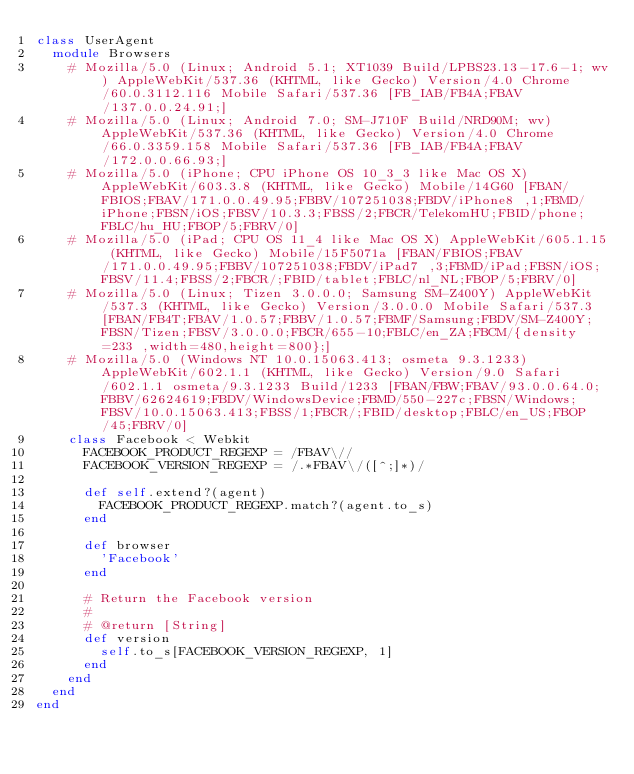Convert code to text. <code><loc_0><loc_0><loc_500><loc_500><_Ruby_>class UserAgent
  module Browsers
    # Mozilla/5.0 (Linux; Android 5.1; XT1039 Build/LPBS23.13-17.6-1; wv) AppleWebKit/537.36 (KHTML, like Gecko) Version/4.0 Chrome/60.0.3112.116 Mobile Safari/537.36 [FB_IAB/FB4A;FBAV/137.0.0.24.91;]
    # Mozilla/5.0 (Linux; Android 7.0; SM-J710F Build/NRD90M; wv) AppleWebKit/537.36 (KHTML, like Gecko) Version/4.0 Chrome/66.0.3359.158 Mobile Safari/537.36 [FB_IAB/FB4A;FBAV/172.0.0.66.93;]
    # Mozilla/5.0 (iPhone; CPU iPhone OS 10_3_3 like Mac OS X) AppleWebKit/603.3.8 (KHTML, like Gecko) Mobile/14G60 [FBAN/FBIOS;FBAV/171.0.0.49.95;FBBV/107251038;FBDV/iPhone8 ,1;FBMD/iPhone;FBSN/iOS;FBSV/10.3.3;FBSS/2;FBCR/TelekomHU;FBID/phone;FBLC/hu_HU;FBOP/5;FBRV/0]
    # Mozilla/5.0 (iPad; CPU OS 11_4 like Mac OS X) AppleWebKit/605.1.15 (KHTML, like Gecko) Mobile/15F5071a [FBAN/FBIOS;FBAV/171.0.0.49.95;FBBV/107251038;FBDV/iPad7 ,3;FBMD/iPad;FBSN/iOS;FBSV/11.4;FBSS/2;FBCR/;FBID/tablet;FBLC/nl_NL;FBOP/5;FBRV/0]
    # Mozilla/5.0 (Linux; Tizen 3.0.0.0; Samsung SM-Z400Y) AppleWebKit/537.3 (KHTML, like Gecko) Version/3.0.0.0 Mobile Safari/537.3 [FBAN/FB4T;FBAV/1.0.57;FBBV/1.0.57;FBMF/Samsung;FBDV/SM-Z400Y;FBSN/Tizen;FBSV/3.0.0.0;FBCR/655-10;FBLC/en_ZA;FBCM/{density=233 ,width=480,height=800};]
    # Mozilla/5.0 (Windows NT 10.0.15063.413; osmeta 9.3.1233) AppleWebKit/602.1.1 (KHTML, like Gecko) Version/9.0 Safari/602.1.1 osmeta/9.3.1233 Build/1233 [FBAN/FBW;FBAV/93.0.0.64.0;FBBV/62624619;FBDV/WindowsDevice;FBMD/550-227c;FBSN/Windows;FBSV/10.0.15063.413;FBSS/1;FBCR/;FBID/desktop;FBLC/en_US;FBOP/45;FBRV/0]
    class Facebook < Webkit
      FACEBOOK_PRODUCT_REGEXP = /FBAV\//
      FACEBOOK_VERSION_REGEXP = /.*FBAV\/([^;]*)/

      def self.extend?(agent)
        FACEBOOK_PRODUCT_REGEXP.match?(agent.to_s)
      end

      def browser
        'Facebook'
      end

      # Return the Facebook version
      #
      # @return [String]
      def version
        self.to_s[FACEBOOK_VERSION_REGEXP, 1]
      end
    end
  end
end
</code> 